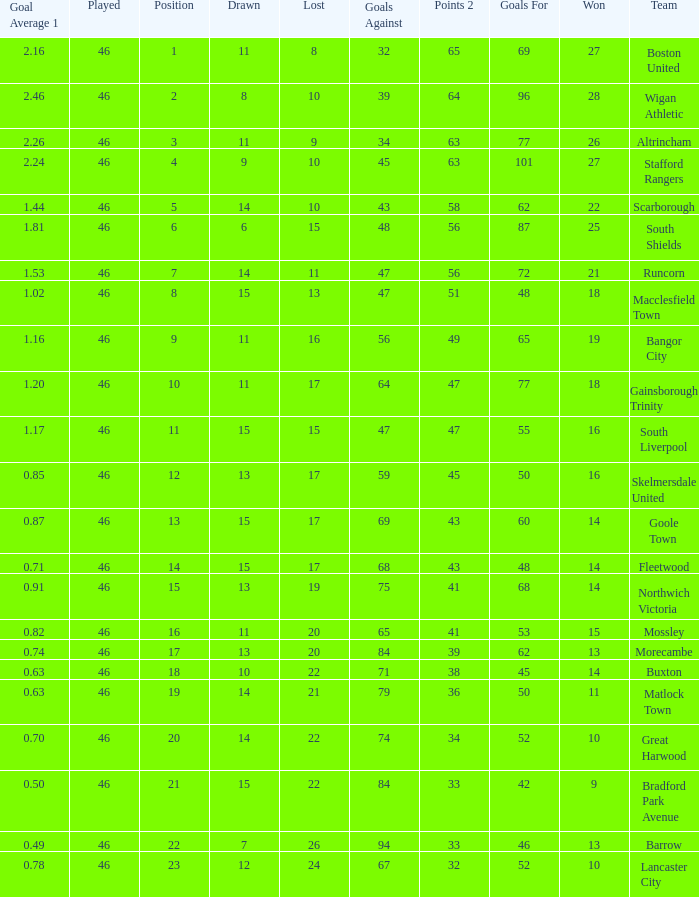How many games did the team who scored 60 goals win? 14.0. Could you parse the entire table as a dict? {'header': ['Goal Average 1', 'Played', 'Position', 'Drawn', 'Lost', 'Goals Against', 'Points 2', 'Goals For', 'Won', 'Team'], 'rows': [['2.16', '46', '1', '11', '8', '32', '65', '69', '27', 'Boston United'], ['2.46', '46', '2', '8', '10', '39', '64', '96', '28', 'Wigan Athletic'], ['2.26', '46', '3', '11', '9', '34', '63', '77', '26', 'Altrincham'], ['2.24', '46', '4', '9', '10', '45', '63', '101', '27', 'Stafford Rangers'], ['1.44', '46', '5', '14', '10', '43', '58', '62', '22', 'Scarborough'], ['1.81', '46', '6', '6', '15', '48', '56', '87', '25', 'South Shields'], ['1.53', '46', '7', '14', '11', '47', '56', '72', '21', 'Runcorn'], ['1.02', '46', '8', '15', '13', '47', '51', '48', '18', 'Macclesfield Town'], ['1.16', '46', '9', '11', '16', '56', '49', '65', '19', 'Bangor City'], ['1.20', '46', '10', '11', '17', '64', '47', '77', '18', 'Gainsborough Trinity'], ['1.17', '46', '11', '15', '15', '47', '47', '55', '16', 'South Liverpool'], ['0.85', '46', '12', '13', '17', '59', '45', '50', '16', 'Skelmersdale United'], ['0.87', '46', '13', '15', '17', '69', '43', '60', '14', 'Goole Town'], ['0.71', '46', '14', '15', '17', '68', '43', '48', '14', 'Fleetwood'], ['0.91', '46', '15', '13', '19', '75', '41', '68', '14', 'Northwich Victoria'], ['0.82', '46', '16', '11', '20', '65', '41', '53', '15', 'Mossley'], ['0.74', '46', '17', '13', '20', '84', '39', '62', '13', 'Morecambe'], ['0.63', '46', '18', '10', '22', '71', '38', '45', '14', 'Buxton'], ['0.63', '46', '19', '14', '21', '79', '36', '50', '11', 'Matlock Town'], ['0.70', '46', '20', '14', '22', '74', '34', '52', '10', 'Great Harwood'], ['0.50', '46', '21', '15', '22', '84', '33', '42', '9', 'Bradford Park Avenue'], ['0.49', '46', '22', '7', '26', '94', '33', '46', '13', 'Barrow'], ['0.78', '46', '23', '12', '24', '67', '32', '52', '10', 'Lancaster City']]} 